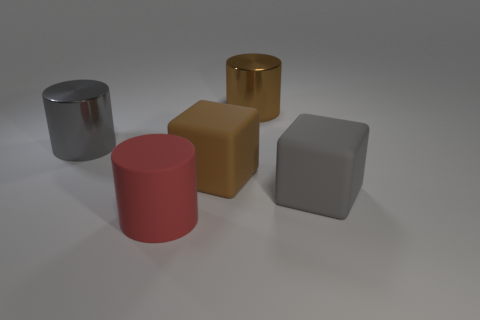Add 5 cyan rubber things. How many objects exist? 10 Subtract all cylinders. How many objects are left? 2 Subtract 0 blue cubes. How many objects are left? 5 Subtract all rubber objects. Subtract all tiny yellow metal balls. How many objects are left? 2 Add 2 big gray objects. How many big gray objects are left? 4 Add 4 brown matte blocks. How many brown matte blocks exist? 5 